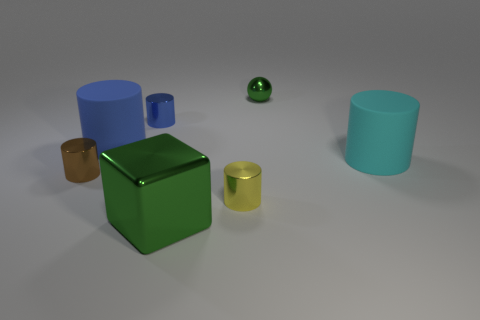Subtract all tiny blue metallic cylinders. How many cylinders are left? 4 Subtract 1 cylinders. How many cylinders are left? 4 Subtract all brown cylinders. How many cylinders are left? 4 Subtract all brown cylinders. Subtract all purple spheres. How many cylinders are left? 4 Add 1 large matte things. How many objects exist? 8 Subtract all balls. How many objects are left? 6 Add 4 green things. How many green things are left? 6 Add 6 large brown things. How many large brown things exist? 6 Subtract 1 cyan cylinders. How many objects are left? 6 Subtract all big green things. Subtract all rubber things. How many objects are left? 4 